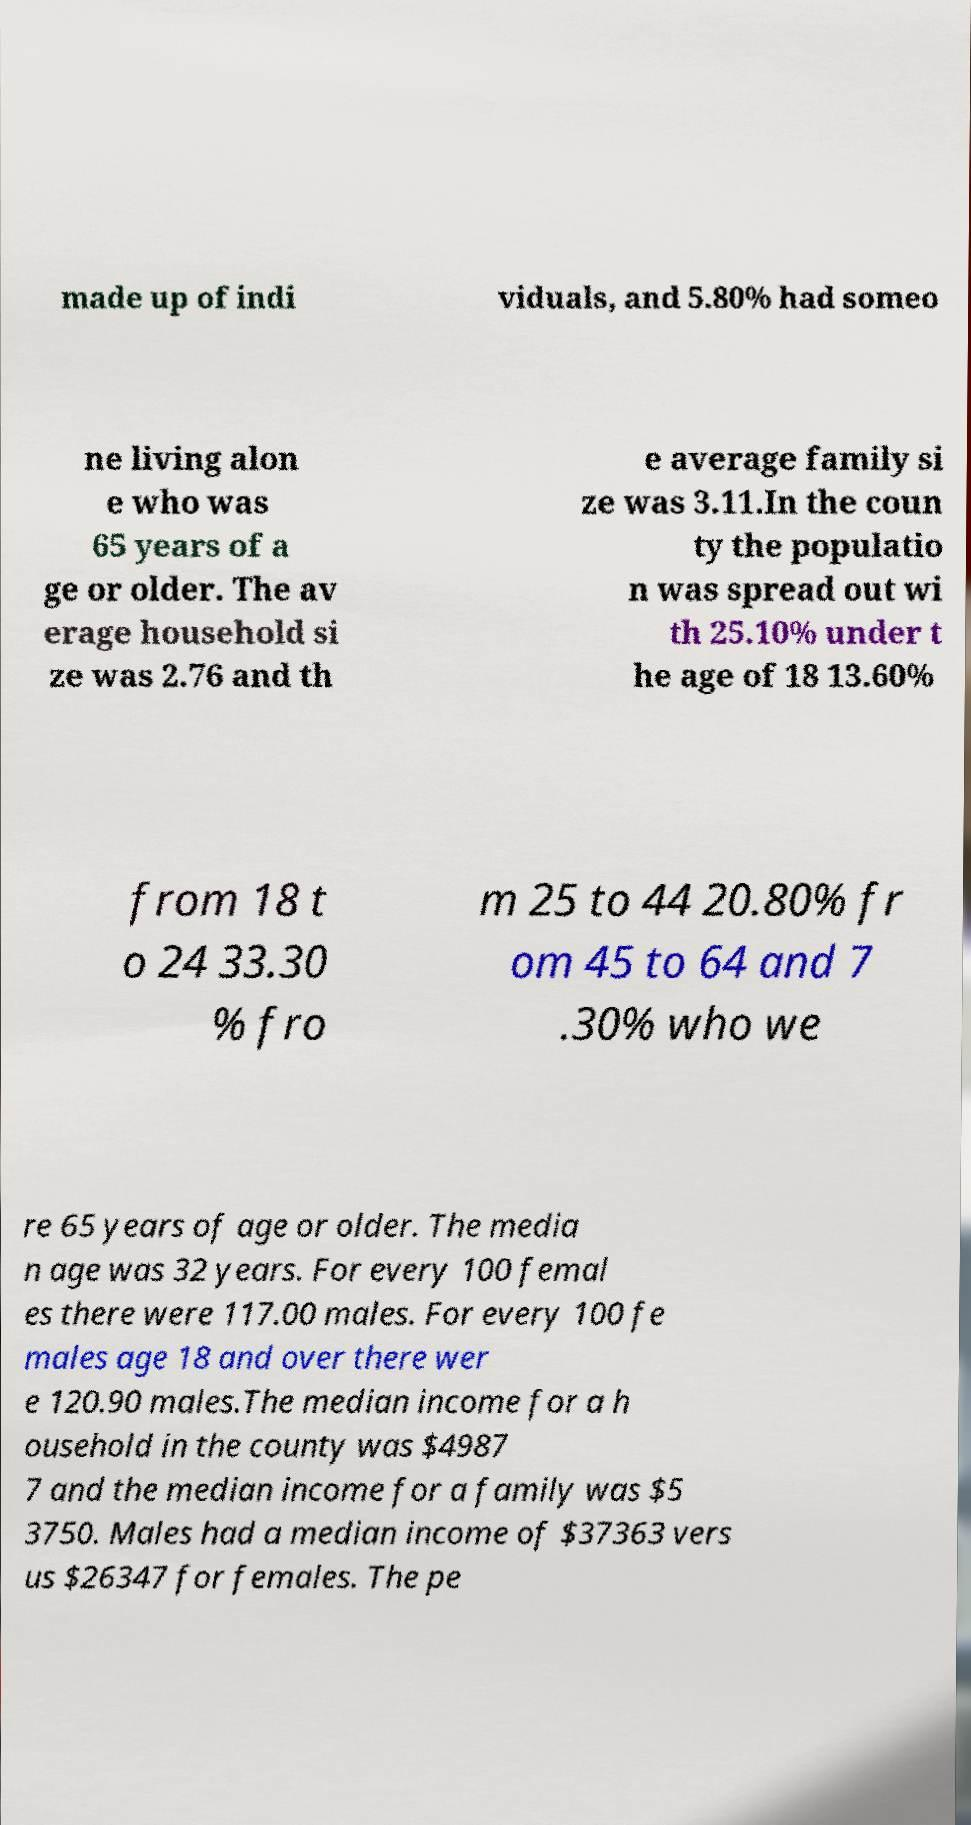Can you accurately transcribe the text from the provided image for me? made up of indi viduals, and 5.80% had someo ne living alon e who was 65 years of a ge or older. The av erage household si ze was 2.76 and th e average family si ze was 3.11.In the coun ty the populatio n was spread out wi th 25.10% under t he age of 18 13.60% from 18 t o 24 33.30 % fro m 25 to 44 20.80% fr om 45 to 64 and 7 .30% who we re 65 years of age or older. The media n age was 32 years. For every 100 femal es there were 117.00 males. For every 100 fe males age 18 and over there wer e 120.90 males.The median income for a h ousehold in the county was $4987 7 and the median income for a family was $5 3750. Males had a median income of $37363 vers us $26347 for females. The pe 